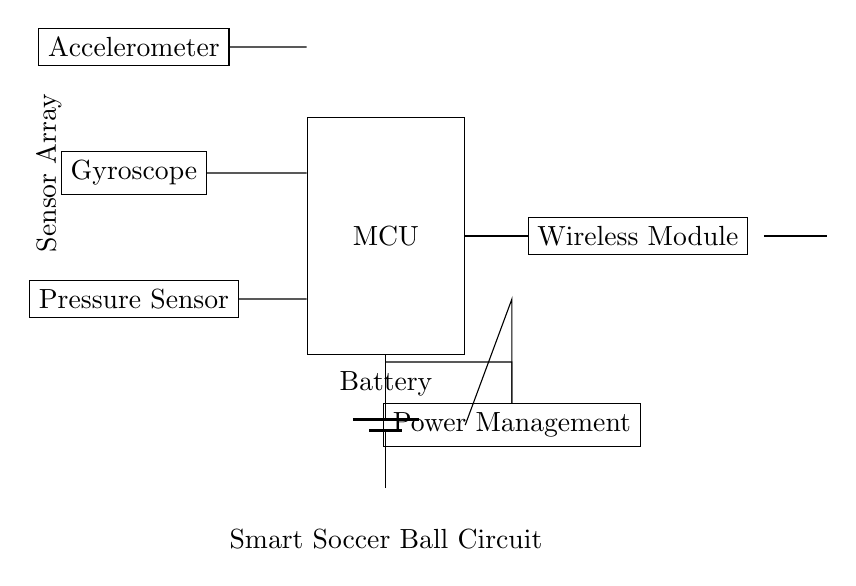What type of sensors are included in the circuit? The circuit includes an accelerometer, a gyroscope, and a pressure sensor. These are identified as separate components in the circuit diagram, each labeled accordingly.
Answer: Accelerometer, gyroscope, pressure sensor How many connections can be identified in this circuit diagram? Counting the visible connections, there are four main connections from the sensors to the microcontroller, and several connections for power and wireless transmission, resulting in a total of approximately eight visible connections.
Answer: Eight What is the role of the microcontroller in this circuit? The microcontroller serves as the central processing unit that receives data from the sensors and communicates with the wireless module. Its placement in the center of the circuit connects directly with all sensors and the wireless module.
Answer: Central processing What component provides power to the circuit? The battery is the component that supplies power to the circuit, as indicated by its position at the bottom and its direct connection to the microcontroller.
Answer: Battery Which component is responsible for wireless data transmission? The wireless module is responsible for transmitting data wirelessly, identified on the right side of the circuit diagram, with a direct connection to the microcontroller.
Answer: Wireless module What does the power management unit do in this circuit? The power management unit regulates the voltage and current to the different components, ensuring they operate within safe limits. The presence of this unit indicates careful design to manage power consumption.
Answer: Regulates power Where is the antenna located in relation to the other components? The antenna is located to the far right of the circuit diagram, indicating it is positioned away from the other components but connected to the wireless module for data transmission.
Answer: Far right 